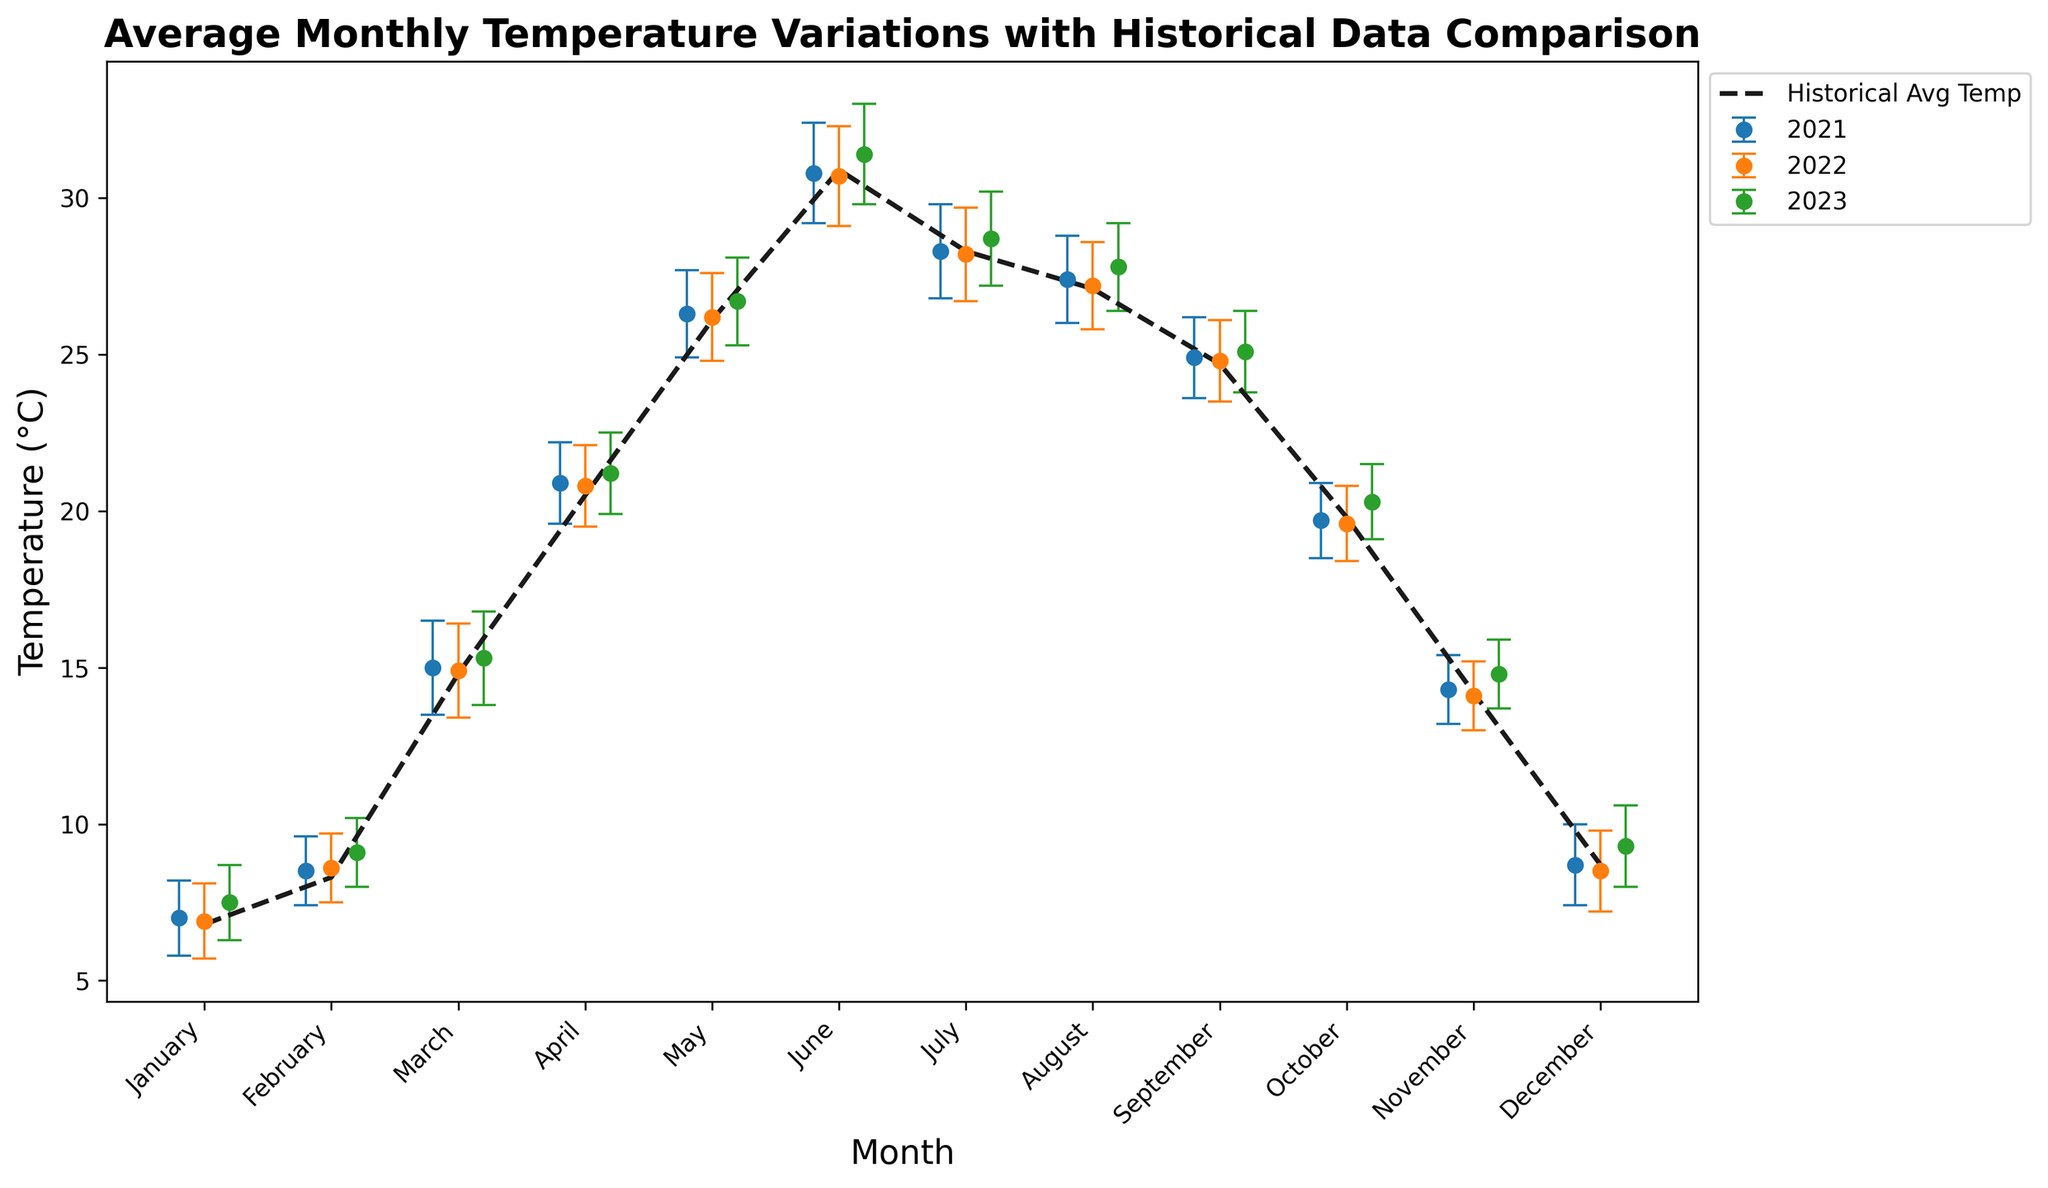Which month has the highest average temperature in 2023? The plot includes the average temperatures for each month in 2023. By locating the highest point in the graph for the year 2023, it's clear that June has the highest average temperature.
Answer: June What is the difference between the average temperature in March 2023 and the historical average temperature for March? From the graph, find the average temperature for March 2023 and the historical average. Subtract the historical average from the March 2023 temperature (15.3°C - 14.8°C).
Answer: 0.5°C In which month is the error bar (standard deviation) the largest for 2023? Error bars represent standard deviation. By visually comparing the error bars' lengths for each month in 2023, June has the largest error bar.
Answer: June Comparing June of 2022 and 2023, which year had a higher average temperature? Locate the average temperatures for June 2022 and June 2023 from the plot and compare them. June 2023 had a higher average temperature of 31.4°C compared to 30.7°C in 2022.
Answer: 2023 What is the average monthly temperature for 2023 averaged over the entire year? Sum the monthly average temperatures for 2023 and divide by 12. The temperatures are: 7.5, 9.1, 15.3, 21.2, 26.7, 31.4, 28.7, 27.8, 25.1, 20.3, 14.8, 9.3. The sum is 237.2, and the average is 237.2 / 12.
Answer: 19.77°C What month shows the least variation in average temperature (smallest standard deviation) in 2023? Identify the smallest standard deviation error bar for each month in 2023. Comparing visually, February has the smallest error bar.
Answer: February Which year's July average temperature equals the historical average temperature exactly? In the plot, find the July data points for each year compared to the historical average temperature line. July 2021 and 2022 show average temperatures matching the historical average.
Answer: 2021 